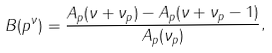Convert formula to latex. <formula><loc_0><loc_0><loc_500><loc_500>B ( p ^ { \nu } ) = \frac { A _ { p } ( \nu + \nu _ { p } ) - A _ { p } ( \nu + \nu _ { p } - 1 ) } { A _ { p } ( \nu _ { p } ) } ,</formula> 